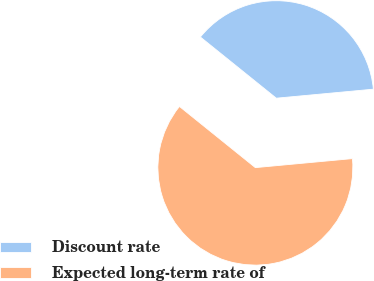Convert chart. <chart><loc_0><loc_0><loc_500><loc_500><pie_chart><fcel>Discount rate<fcel>Expected long-term rate of<nl><fcel>37.73%<fcel>62.27%<nl></chart> 